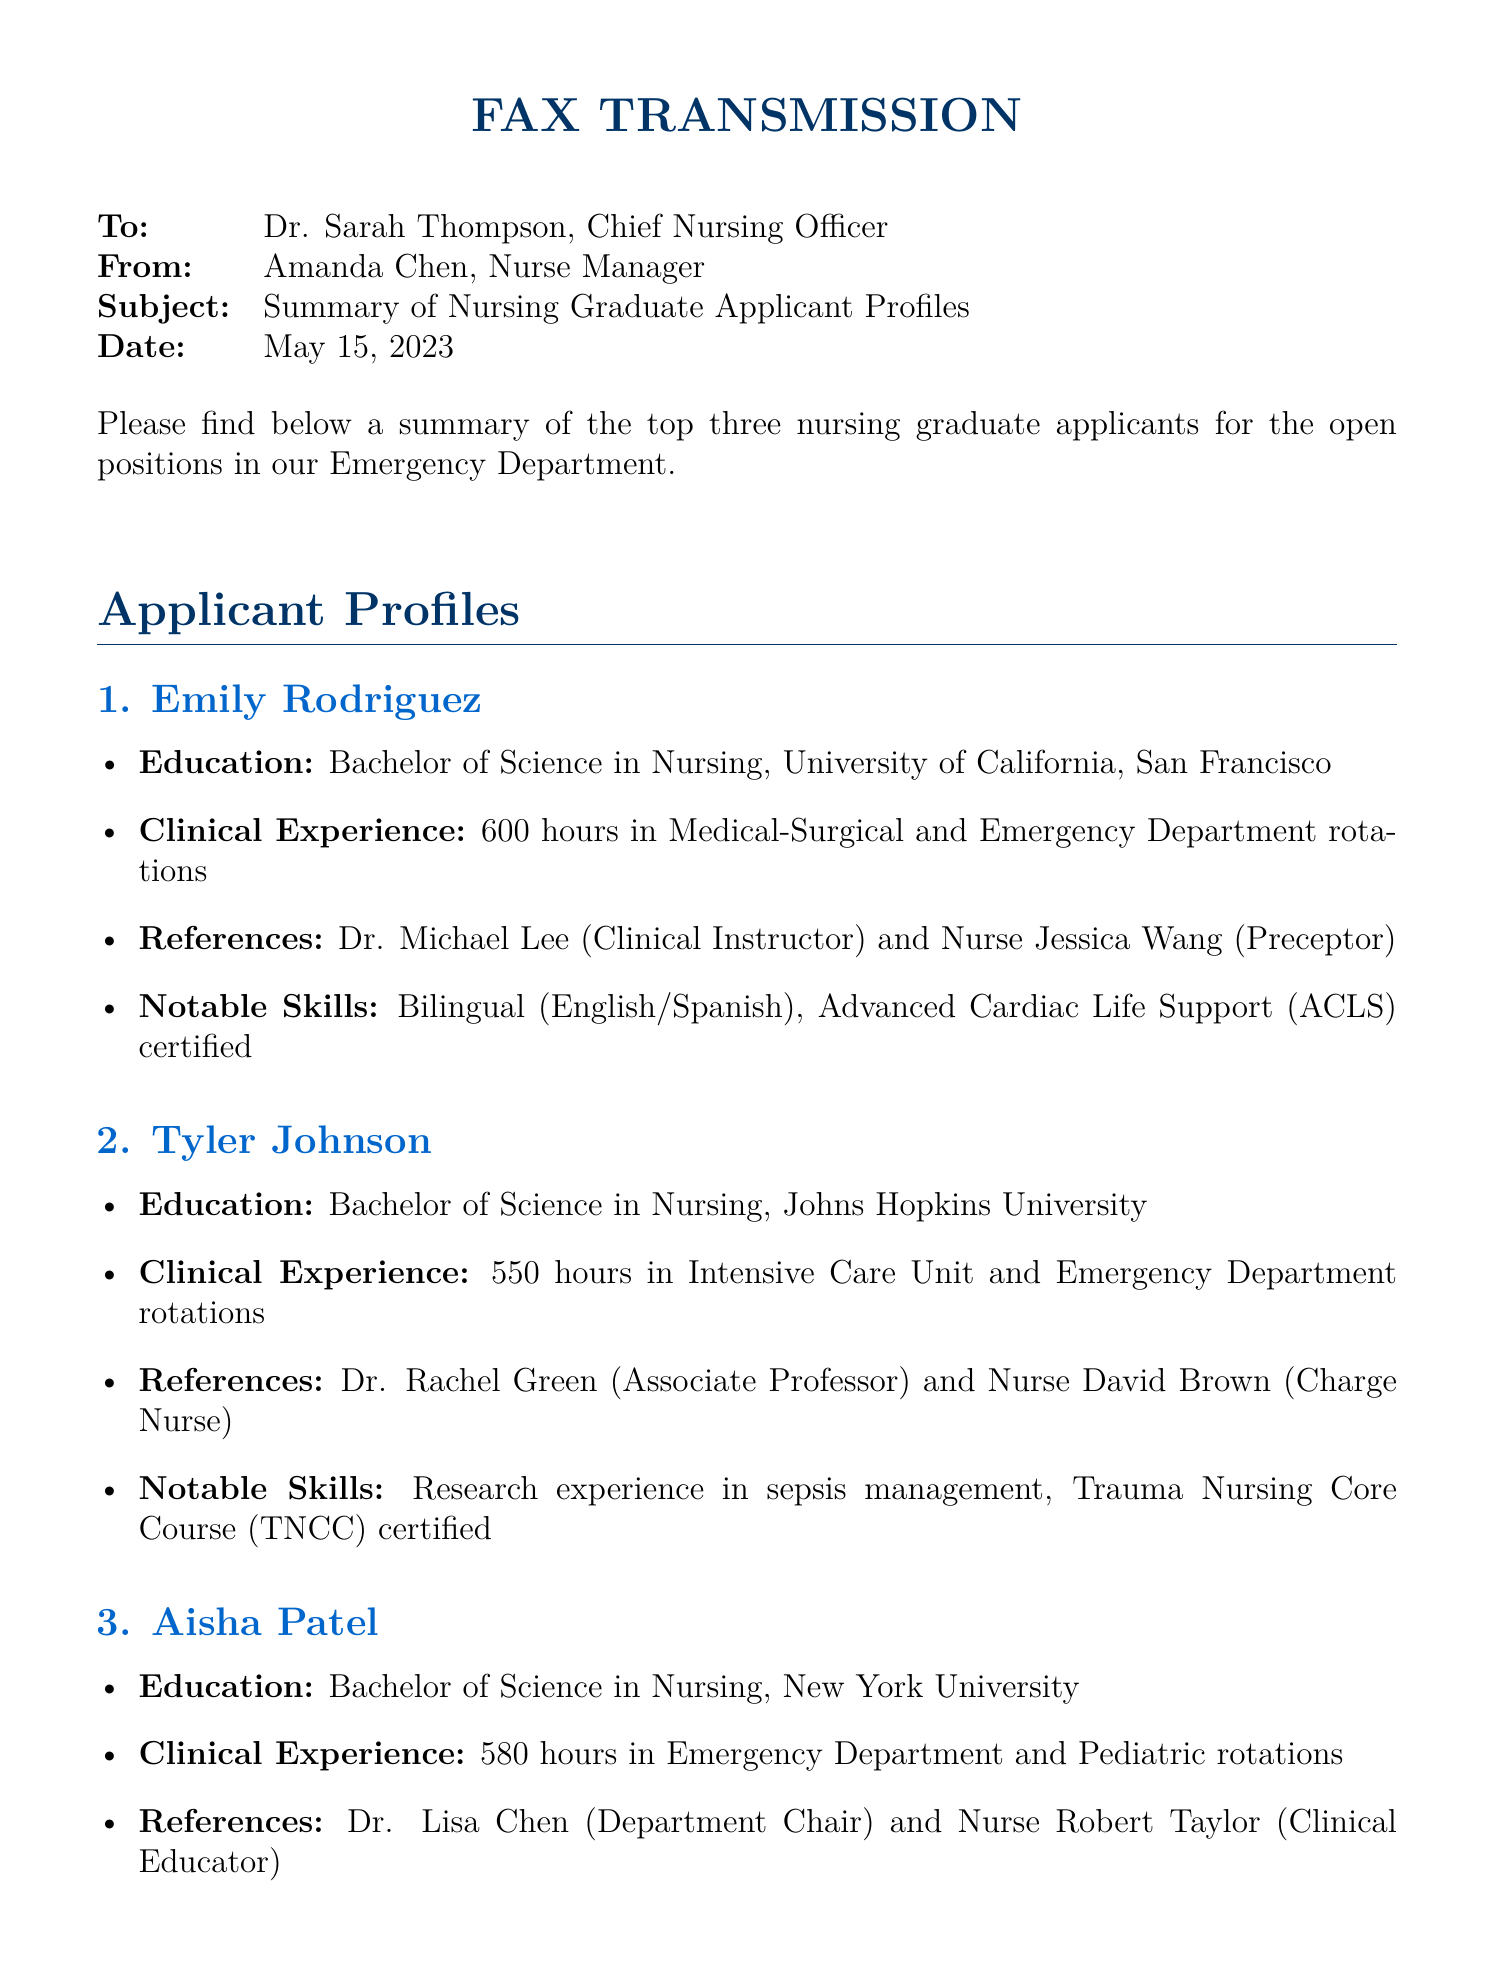What is the date of the fax? The date of the fax is clearly stated at the top of the document.
Answer: May 15, 2023 Who is the first applicant listed? The first applicant's name is provided in the applicant profiles section.
Answer: Emily Rodriguez How many hours of clinical experience does Tyler Johnson have? The number of clinical experience hours is specified in each applicant's profile.
Answer: 550 hours What notable skill does Aisha Patel have related to pediatrics? This skill is mentioned in Aisha's profile under notable skills.
Answer: Pediatric Advanced Life Support (PALS) certified Which university did Emily Rodriguez attend? The applicant's educational background is listed in the profiles.
Answer: University of California, San Francisco How many applicants have listed references? All three applicants' profiles contain references; thus, the total can be derived from the document.
Answer: Three applicants What clinical rotation did Aisha Patel complete? Specific clinical rotations are outlined in each profile, revealing the applicant's experience.
Answer: Emergency Department and Pediatric rotations Who is the second reference for Tyler Johnson? The document specifies both references for each applicant.
Answer: Nurse David Brown (Charge Nurse) What is the subject of the fax? The subject is mentioned directly in the fax header.
Answer: Summary of Nursing Graduate Applicant Profiles 